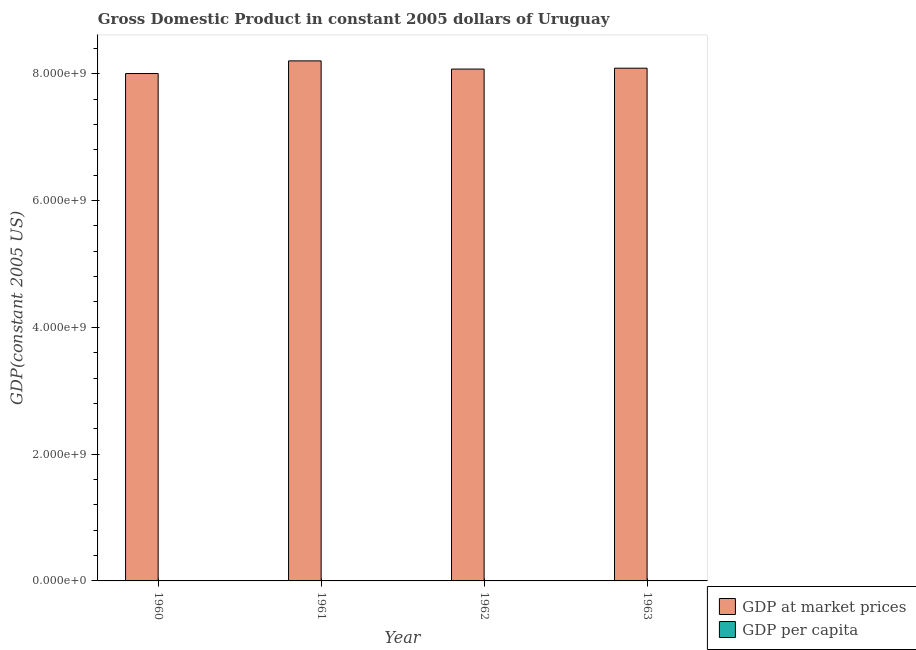How many different coloured bars are there?
Provide a succinct answer. 2. How many groups of bars are there?
Your answer should be very brief. 4. Are the number of bars on each tick of the X-axis equal?
Provide a short and direct response. Yes. How many bars are there on the 2nd tick from the left?
Offer a terse response. 2. In how many cases, is the number of bars for a given year not equal to the number of legend labels?
Your response must be concise. 0. What is the gdp per capita in 1961?
Keep it short and to the point. 3189.04. Across all years, what is the maximum gdp per capita?
Offer a terse response. 3189.04. Across all years, what is the minimum gdp per capita?
Your response must be concise. 3068.48. In which year was the gdp per capita maximum?
Your answer should be compact. 1961. In which year was the gdp per capita minimum?
Your response must be concise. 1963. What is the total gdp at market prices in the graph?
Provide a short and direct response. 3.24e+1. What is the difference between the gdp at market prices in 1961 and that in 1962?
Your answer should be very brief. 1.29e+08. What is the difference between the gdp per capita in 1963 and the gdp at market prices in 1962?
Offer a very short reply. -31.53. What is the average gdp per capita per year?
Your answer should be compact. 3127.37. What is the ratio of the gdp at market prices in 1960 to that in 1963?
Provide a short and direct response. 0.99. What is the difference between the highest and the second highest gdp per capita?
Give a very brief answer. 37.07. What is the difference between the highest and the lowest gdp per capita?
Your response must be concise. 120.55. In how many years, is the gdp per capita greater than the average gdp per capita taken over all years?
Give a very brief answer. 2. What does the 2nd bar from the left in 1962 represents?
Keep it short and to the point. GDP per capita. What does the 1st bar from the right in 1962 represents?
Make the answer very short. GDP per capita. How many bars are there?
Your answer should be compact. 8. Are all the bars in the graph horizontal?
Provide a succinct answer. No. Are the values on the major ticks of Y-axis written in scientific E-notation?
Your response must be concise. Yes. Does the graph contain any zero values?
Offer a very short reply. No. Does the graph contain grids?
Your answer should be compact. No. Where does the legend appear in the graph?
Your response must be concise. Bottom right. What is the title of the graph?
Provide a short and direct response. Gross Domestic Product in constant 2005 dollars of Uruguay. Does "Under-five" appear as one of the legend labels in the graph?
Offer a terse response. No. What is the label or title of the X-axis?
Offer a very short reply. Year. What is the label or title of the Y-axis?
Provide a succinct answer. GDP(constant 2005 US). What is the GDP(constant 2005 US) in GDP at market prices in 1960?
Offer a terse response. 8.00e+09. What is the GDP(constant 2005 US) in GDP per capita in 1960?
Keep it short and to the point. 3151.96. What is the GDP(constant 2005 US) of GDP at market prices in 1961?
Keep it short and to the point. 8.20e+09. What is the GDP(constant 2005 US) of GDP per capita in 1961?
Provide a short and direct response. 3189.04. What is the GDP(constant 2005 US) in GDP at market prices in 1962?
Keep it short and to the point. 8.07e+09. What is the GDP(constant 2005 US) in GDP per capita in 1962?
Your response must be concise. 3100.01. What is the GDP(constant 2005 US) of GDP at market prices in 1963?
Keep it short and to the point. 8.09e+09. What is the GDP(constant 2005 US) of GDP per capita in 1963?
Your answer should be very brief. 3068.48. Across all years, what is the maximum GDP(constant 2005 US) in GDP at market prices?
Provide a succinct answer. 8.20e+09. Across all years, what is the maximum GDP(constant 2005 US) of GDP per capita?
Your answer should be compact. 3189.04. Across all years, what is the minimum GDP(constant 2005 US) of GDP at market prices?
Give a very brief answer. 8.00e+09. Across all years, what is the minimum GDP(constant 2005 US) in GDP per capita?
Your answer should be compact. 3068.48. What is the total GDP(constant 2005 US) in GDP at market prices in the graph?
Your response must be concise. 3.24e+1. What is the total GDP(constant 2005 US) of GDP per capita in the graph?
Provide a short and direct response. 1.25e+04. What is the difference between the GDP(constant 2005 US) of GDP at market prices in 1960 and that in 1961?
Make the answer very short. -1.99e+08. What is the difference between the GDP(constant 2005 US) in GDP per capita in 1960 and that in 1961?
Your response must be concise. -37.08. What is the difference between the GDP(constant 2005 US) in GDP at market prices in 1960 and that in 1962?
Ensure brevity in your answer.  -7.04e+07. What is the difference between the GDP(constant 2005 US) in GDP per capita in 1960 and that in 1962?
Keep it short and to the point. 51.95. What is the difference between the GDP(constant 2005 US) in GDP at market prices in 1960 and that in 1963?
Your answer should be very brief. -8.41e+07. What is the difference between the GDP(constant 2005 US) in GDP per capita in 1960 and that in 1963?
Offer a very short reply. 83.48. What is the difference between the GDP(constant 2005 US) in GDP at market prices in 1961 and that in 1962?
Provide a short and direct response. 1.29e+08. What is the difference between the GDP(constant 2005 US) of GDP per capita in 1961 and that in 1962?
Provide a succinct answer. 89.02. What is the difference between the GDP(constant 2005 US) in GDP at market prices in 1961 and that in 1963?
Make the answer very short. 1.15e+08. What is the difference between the GDP(constant 2005 US) in GDP per capita in 1961 and that in 1963?
Your answer should be very brief. 120.55. What is the difference between the GDP(constant 2005 US) in GDP at market prices in 1962 and that in 1963?
Offer a very short reply. -1.38e+07. What is the difference between the GDP(constant 2005 US) of GDP per capita in 1962 and that in 1963?
Your answer should be very brief. 31.53. What is the difference between the GDP(constant 2005 US) of GDP at market prices in 1960 and the GDP(constant 2005 US) of GDP per capita in 1961?
Provide a succinct answer. 8.00e+09. What is the difference between the GDP(constant 2005 US) in GDP at market prices in 1960 and the GDP(constant 2005 US) in GDP per capita in 1962?
Your response must be concise. 8.00e+09. What is the difference between the GDP(constant 2005 US) of GDP at market prices in 1960 and the GDP(constant 2005 US) of GDP per capita in 1963?
Provide a succinct answer. 8.00e+09. What is the difference between the GDP(constant 2005 US) of GDP at market prices in 1961 and the GDP(constant 2005 US) of GDP per capita in 1962?
Keep it short and to the point. 8.20e+09. What is the difference between the GDP(constant 2005 US) in GDP at market prices in 1961 and the GDP(constant 2005 US) in GDP per capita in 1963?
Keep it short and to the point. 8.20e+09. What is the difference between the GDP(constant 2005 US) of GDP at market prices in 1962 and the GDP(constant 2005 US) of GDP per capita in 1963?
Provide a succinct answer. 8.07e+09. What is the average GDP(constant 2005 US) of GDP at market prices per year?
Offer a very short reply. 8.09e+09. What is the average GDP(constant 2005 US) in GDP per capita per year?
Provide a short and direct response. 3127.37. In the year 1960, what is the difference between the GDP(constant 2005 US) of GDP at market prices and GDP(constant 2005 US) of GDP per capita?
Keep it short and to the point. 8.00e+09. In the year 1961, what is the difference between the GDP(constant 2005 US) in GDP at market prices and GDP(constant 2005 US) in GDP per capita?
Your response must be concise. 8.20e+09. In the year 1962, what is the difference between the GDP(constant 2005 US) in GDP at market prices and GDP(constant 2005 US) in GDP per capita?
Provide a short and direct response. 8.07e+09. In the year 1963, what is the difference between the GDP(constant 2005 US) of GDP at market prices and GDP(constant 2005 US) of GDP per capita?
Keep it short and to the point. 8.09e+09. What is the ratio of the GDP(constant 2005 US) in GDP at market prices in 1960 to that in 1961?
Provide a succinct answer. 0.98. What is the ratio of the GDP(constant 2005 US) of GDP per capita in 1960 to that in 1961?
Give a very brief answer. 0.99. What is the ratio of the GDP(constant 2005 US) in GDP at market prices in 1960 to that in 1962?
Make the answer very short. 0.99. What is the ratio of the GDP(constant 2005 US) of GDP per capita in 1960 to that in 1962?
Ensure brevity in your answer.  1.02. What is the ratio of the GDP(constant 2005 US) in GDP at market prices in 1960 to that in 1963?
Provide a short and direct response. 0.99. What is the ratio of the GDP(constant 2005 US) of GDP per capita in 1960 to that in 1963?
Give a very brief answer. 1.03. What is the ratio of the GDP(constant 2005 US) in GDP at market prices in 1961 to that in 1962?
Ensure brevity in your answer.  1.02. What is the ratio of the GDP(constant 2005 US) in GDP per capita in 1961 to that in 1962?
Offer a terse response. 1.03. What is the ratio of the GDP(constant 2005 US) in GDP at market prices in 1961 to that in 1963?
Provide a succinct answer. 1.01. What is the ratio of the GDP(constant 2005 US) in GDP per capita in 1961 to that in 1963?
Your answer should be compact. 1.04. What is the ratio of the GDP(constant 2005 US) in GDP at market prices in 1962 to that in 1963?
Your response must be concise. 1. What is the ratio of the GDP(constant 2005 US) in GDP per capita in 1962 to that in 1963?
Your answer should be very brief. 1.01. What is the difference between the highest and the second highest GDP(constant 2005 US) in GDP at market prices?
Make the answer very short. 1.15e+08. What is the difference between the highest and the second highest GDP(constant 2005 US) of GDP per capita?
Give a very brief answer. 37.08. What is the difference between the highest and the lowest GDP(constant 2005 US) in GDP at market prices?
Provide a short and direct response. 1.99e+08. What is the difference between the highest and the lowest GDP(constant 2005 US) in GDP per capita?
Your response must be concise. 120.55. 